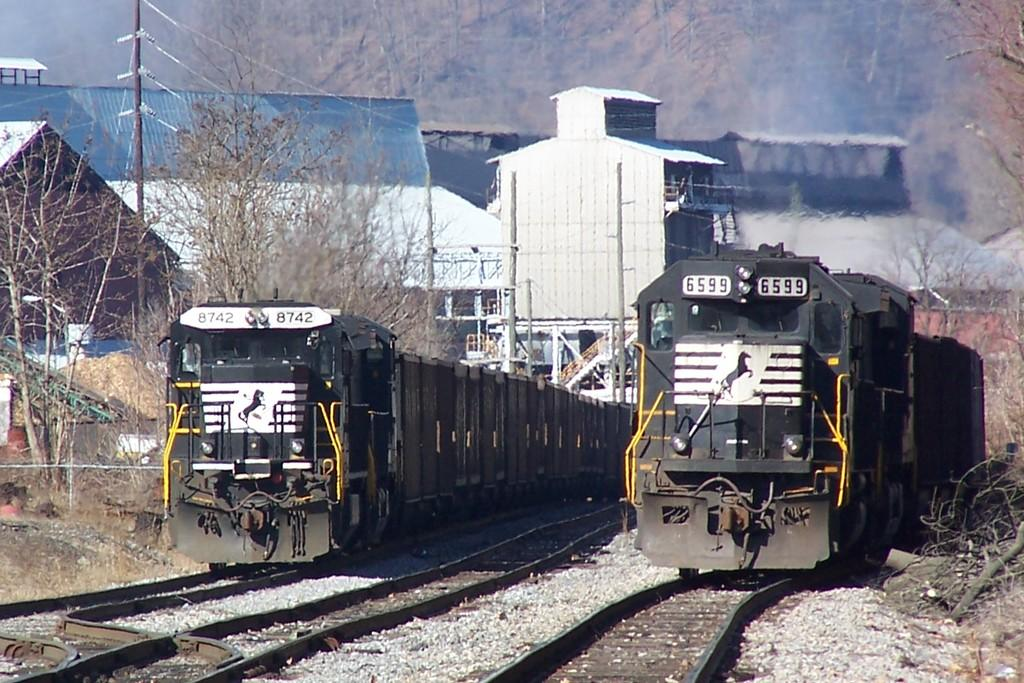How many trains are visible on the track in the image? There are two trains on the track in the image. What is the arrangement of the tracks in the image? There is an additional track between the two trains. What can be seen in the background of the image? There are trees, a utility pole, and buildings in the background of the image. How many stitches are visible on the train in the image? There are no stitches visible on the trains in the image, as trains are not made of fabric or material that requires stitching. 